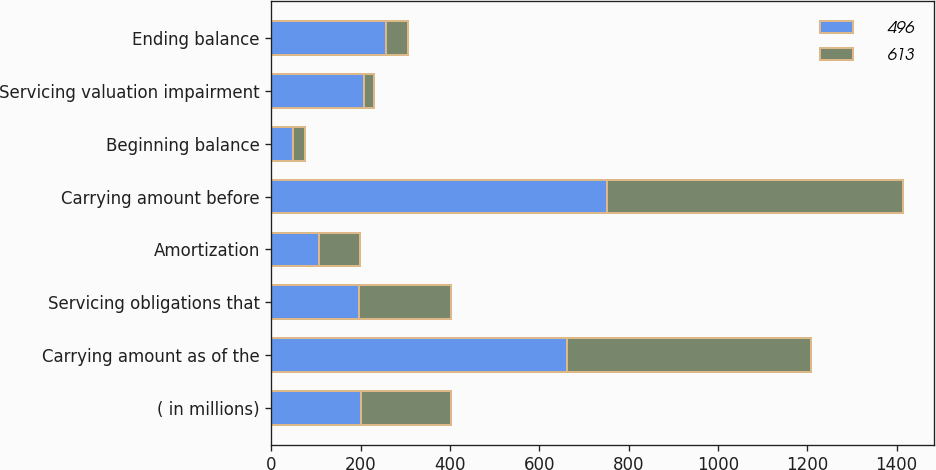Convert chart. <chart><loc_0><loc_0><loc_500><loc_500><stacked_bar_chart><ecel><fcel>( in millions)<fcel>Carrying amount as of the<fcel>Servicing obligations that<fcel>Amortization<fcel>Carrying amount before<fcel>Beginning balance<fcel>Servicing valuation impairment<fcel>Ending balance<nl><fcel>496<fcel>201.5<fcel>662<fcel>196<fcel>107<fcel>752<fcel>49<fcel>207<fcel>256<nl><fcel>613<fcel>201.5<fcel>546<fcel>207<fcel>91<fcel>662<fcel>27<fcel>22<fcel>49<nl></chart> 